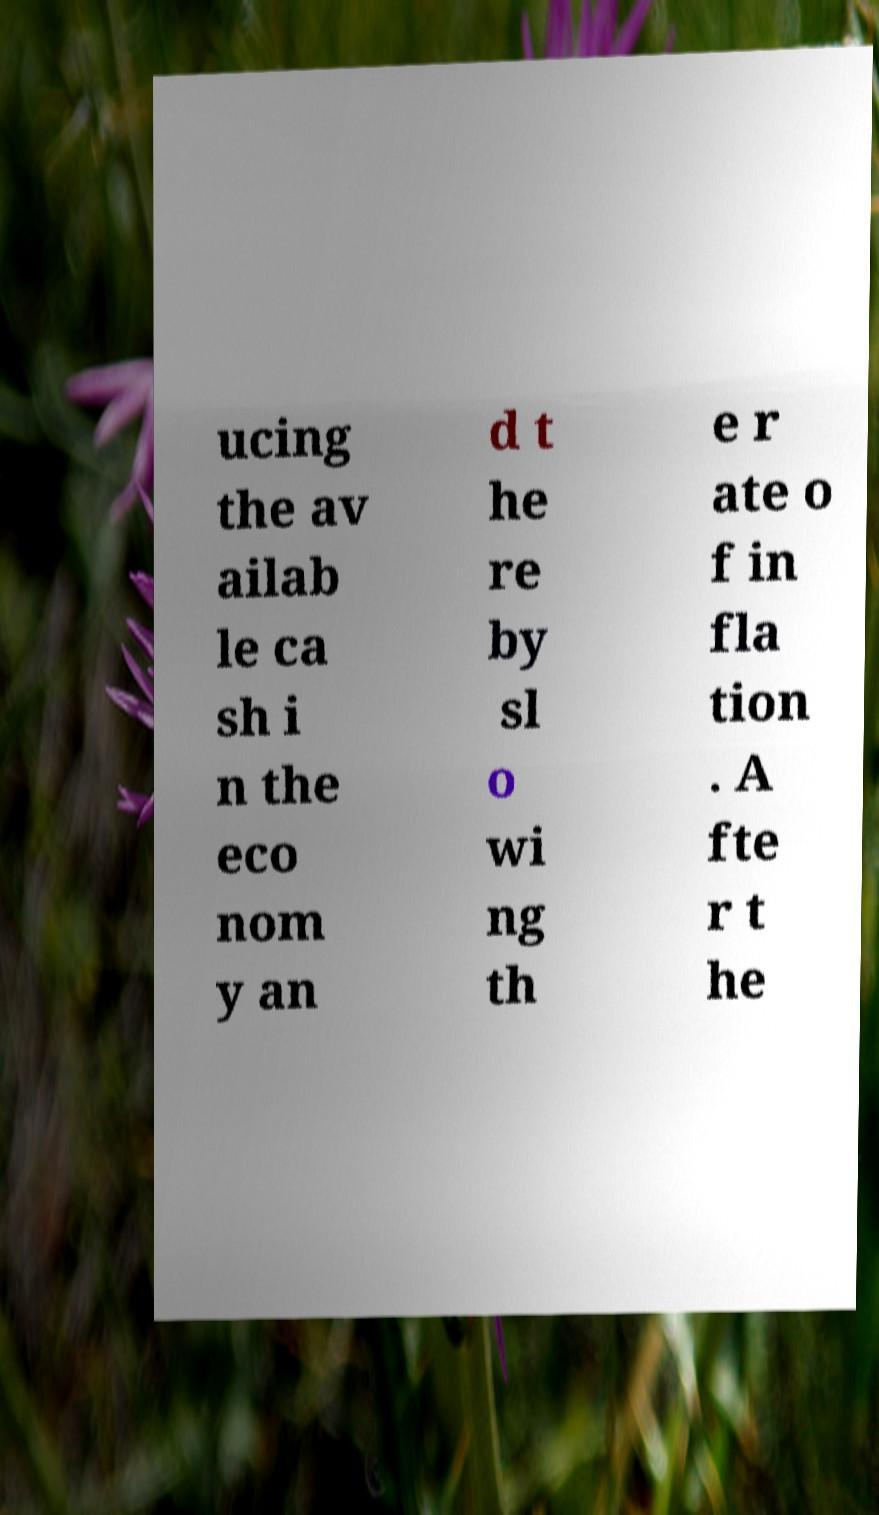Can you accurately transcribe the text from the provided image for me? ucing the av ailab le ca sh i n the eco nom y an d t he re by sl o wi ng th e r ate o f in fla tion . A fte r t he 